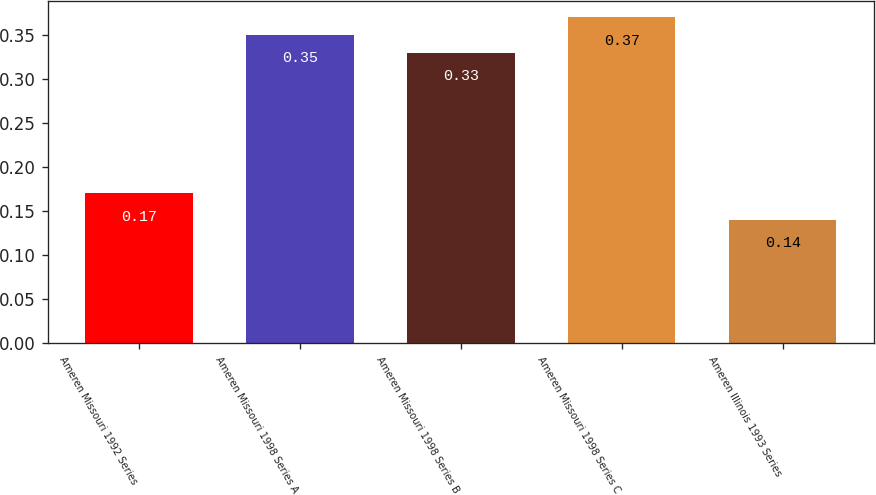Convert chart to OTSL. <chart><loc_0><loc_0><loc_500><loc_500><bar_chart><fcel>Ameren Missouri 1992 Series<fcel>Ameren Missouri 1998 Series A<fcel>Ameren Missouri 1998 Series B<fcel>Ameren Missouri 1998 Series C<fcel>Ameren Illinois 1993 Series<nl><fcel>0.17<fcel>0.35<fcel>0.33<fcel>0.37<fcel>0.14<nl></chart> 